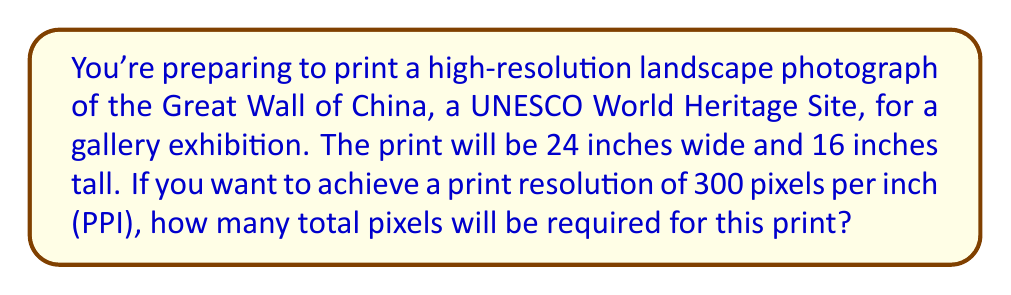Teach me how to tackle this problem. To calculate the total number of pixels required for the high-resolution print, we need to follow these steps:

1. Calculate the number of pixels along the width:
   $$ \text{Width in pixels} = \text{Width in inches} \times \text{PPI} $$
   $$ \text{Width in pixels} = 24 \times 300 = 7,200 \text{ pixels} $$

2. Calculate the number of pixels along the height:
   $$ \text{Height in pixels} = \text{Height in inches} \times \text{PPI} $$
   $$ \text{Height in pixels} = 16 \times 300 = 4,800 \text{ pixels} $$

3. Calculate the total number of pixels by multiplying the width and height in pixels:
   $$ \text{Total pixels} = \text{Width in pixels} \times \text{Height in pixels} $$
   $$ \text{Total pixels} = 7,200 \times 4,800 = 34,560,000 \text{ pixels} $$

This calculation gives us the total number of pixels required for the high-resolution print of the Great Wall of China landscape photograph.
Answer: 34,560,000 pixels 